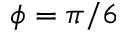<formula> <loc_0><loc_0><loc_500><loc_500>\phi = \pi / 6</formula> 